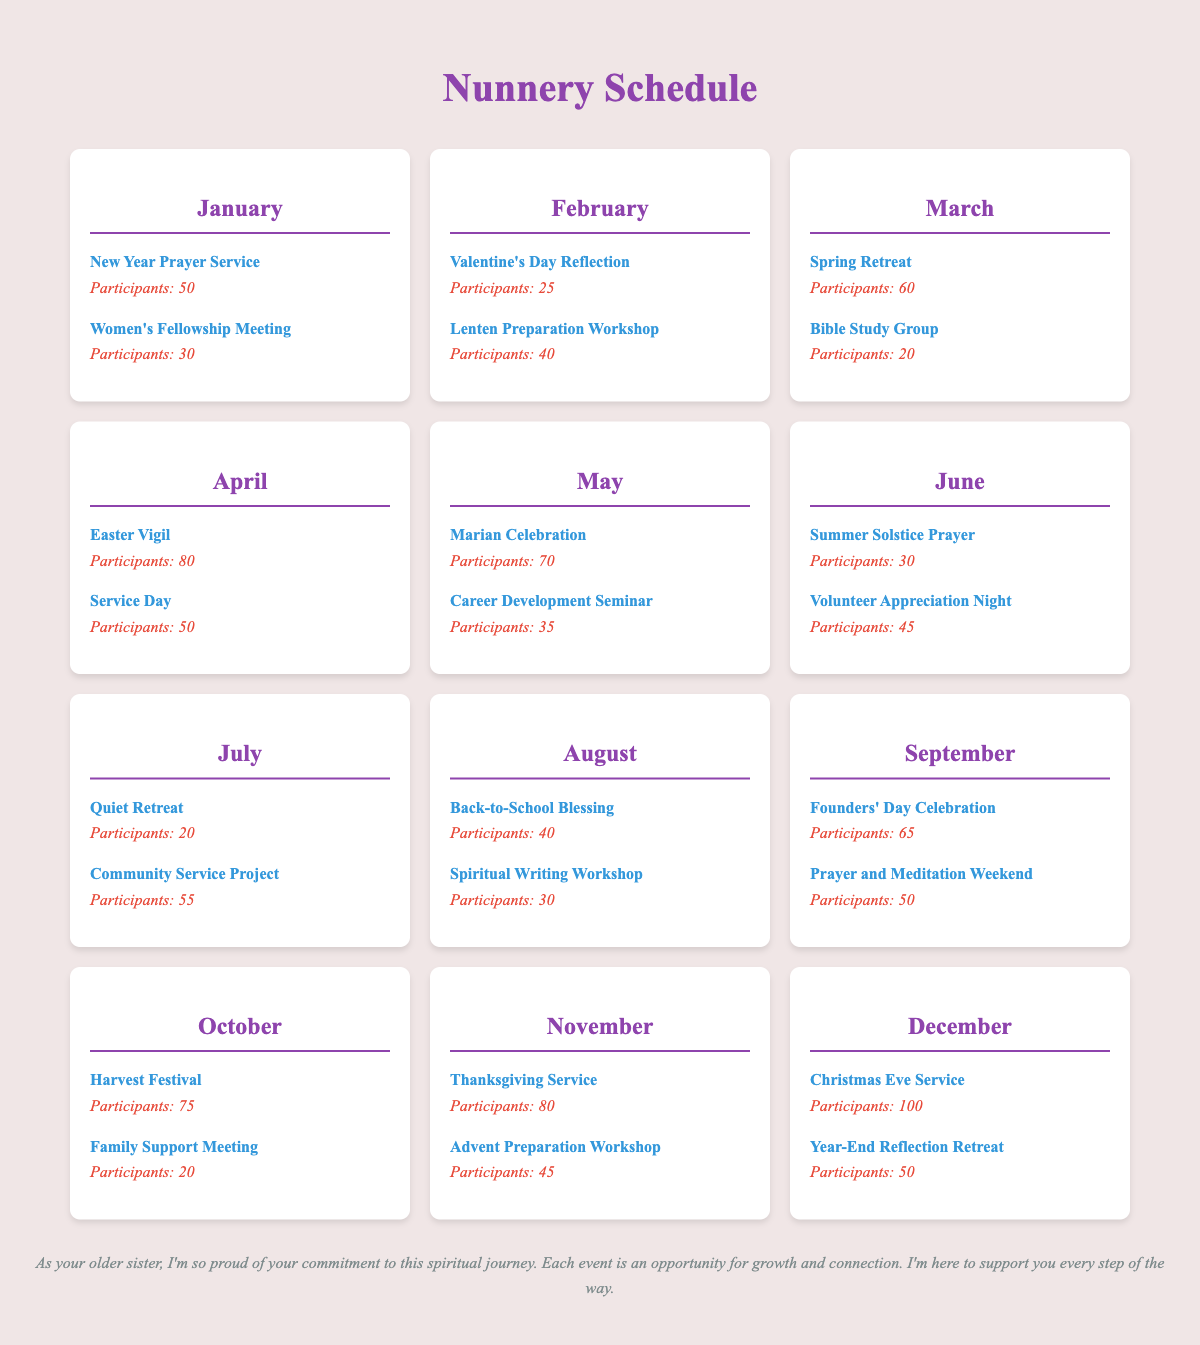What are the total participants for events in April? The events in April include the Easter Vigil with 80 participants and Service Day with 50 participants. Adding them together: 80 + 50 = 130.
Answer: 130 What event had the highest participation? The Christmas Eve Service in December had the highest participation with 100 attendees.
Answer: 100 How many participants attended events in January? In January, the New Year Prayer Service had 50 participants, and the Women's Fellowship Meeting had 30 participants. Adding them up gives: 50 + 30 = 80.
Answer: 80 Which month had the fewest participants across all events, and how many? Looking at all months, July had the fewest total participants with 75 (20 for the Quiet Retreat and 55 for the Community Service Project).
Answer: July, 75 What is the average number of participants per event in November? There are two events in November: the Thanksgiving Service with 80 participants and the Advent Preparation Workshop with 45 participants. The average is: (80 + 45) / 2 = 62.5.
Answer: 62.5 How many participants were there in total for the events in June? In June, the Summer Solstice Prayer had 30 participants, and the Volunteer Appreciation Night had 45. Adding these gives: 30 + 45 = 75.
Answer: 75 Is it true that the number of participants for the Founders' Day Celebration was greater than the Prayer and Meditation Weekend? The Founders' Day Celebration had 65 participants, and the Prayer and Meditation Weekend had 50 participants. Since 65 > 50, the statement is true.
Answer: True What was the difference in participation between the highest attended event in December and the lowest attended event in July? The highest attended event in December was the Christmas Eve Service with 100 participants, and the lowest in July was the Quiet Retreat with 20. The difference is: 100 - 20 = 80.
Answer: 80 Which month had events that collectively attracted the most participants, and how many in total? April had the Easter Vigil with 80 participants and Service Day with 50 participants. The total for April is 130, which is the highest of all months.
Answer: April, 130 How many events had more than 50 participants in September? In September, there are two events: Founders' Day Celebration with 65 participants (more than 50) and Prayer and Meditation Weekend with 50 participants (not more than 50). Only one event has more than 50 participants.
Answer: 1 